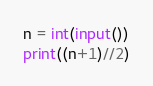<code> <loc_0><loc_0><loc_500><loc_500><_Python_>n = int(input())
print((n+1)//2)</code> 